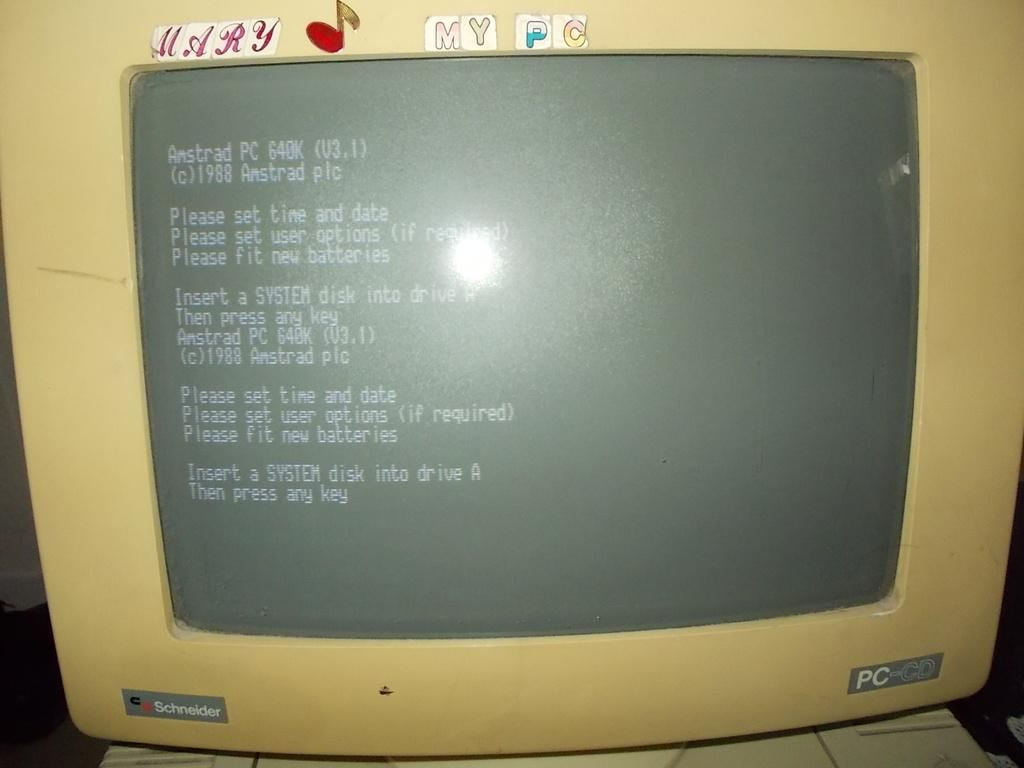<image>
Relay a brief, clear account of the picture shown. an old schneider PC-CD monitor displaying the bios boot screen 